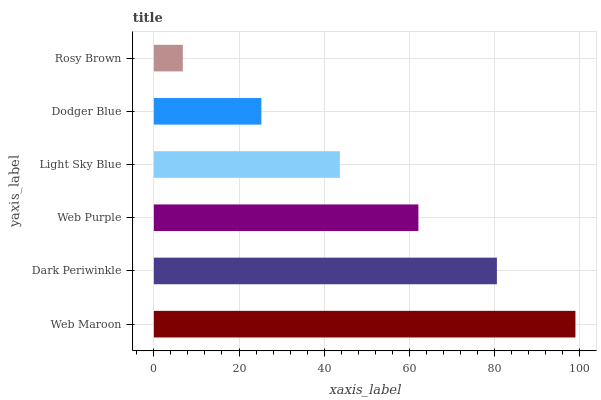Is Rosy Brown the minimum?
Answer yes or no. Yes. Is Web Maroon the maximum?
Answer yes or no. Yes. Is Dark Periwinkle the minimum?
Answer yes or no. No. Is Dark Periwinkle the maximum?
Answer yes or no. No. Is Web Maroon greater than Dark Periwinkle?
Answer yes or no. Yes. Is Dark Periwinkle less than Web Maroon?
Answer yes or no. Yes. Is Dark Periwinkle greater than Web Maroon?
Answer yes or no. No. Is Web Maroon less than Dark Periwinkle?
Answer yes or no. No. Is Web Purple the high median?
Answer yes or no. Yes. Is Light Sky Blue the low median?
Answer yes or no. Yes. Is Dodger Blue the high median?
Answer yes or no. No. Is Dodger Blue the low median?
Answer yes or no. No. 